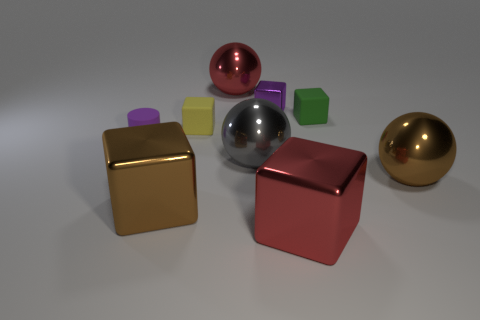Subtract all tiny green cubes. How many cubes are left? 4 Subtract 1 cylinders. How many cylinders are left? 0 Subtract all brown balls. How many balls are left? 2 Subtract all blue cubes. How many brown balls are left? 1 Add 7 small yellow cubes. How many small yellow cubes are left? 8 Add 4 large yellow metal blocks. How many large yellow metal blocks exist? 4 Add 1 green objects. How many objects exist? 10 Subtract 0 cyan cubes. How many objects are left? 9 Subtract all cylinders. How many objects are left? 8 Subtract all yellow balls. Subtract all red blocks. How many balls are left? 3 